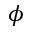Convert formula to latex. <formula><loc_0><loc_0><loc_500><loc_500>\phi</formula> 